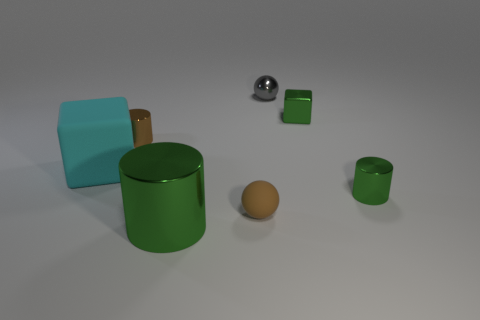Add 1 shiny cylinders. How many objects exist? 8 Subtract all blocks. How many objects are left? 5 Add 2 green objects. How many green objects are left? 5 Add 1 large green things. How many large green things exist? 2 Subtract 0 purple cylinders. How many objects are left? 7 Subtract all large cyan spheres. Subtract all green metallic cubes. How many objects are left? 6 